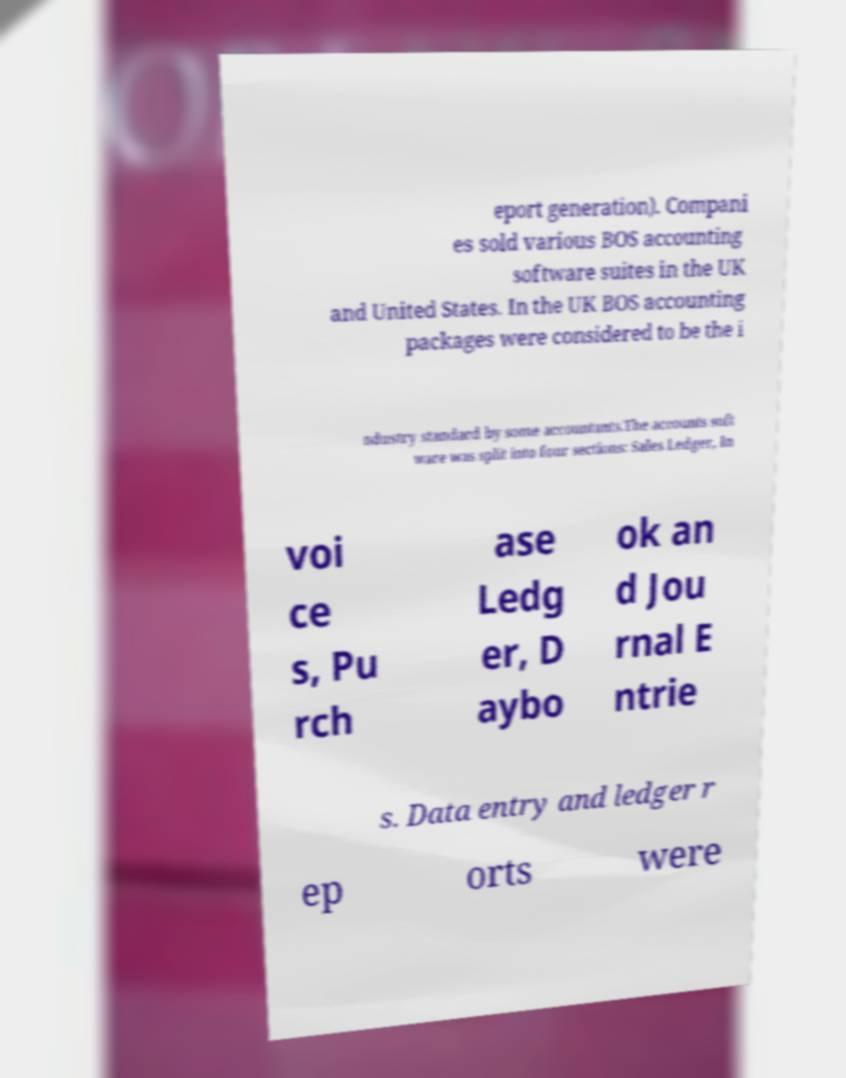For documentation purposes, I need the text within this image transcribed. Could you provide that? eport generation). Compani es sold various BOS accounting software suites in the UK and United States. In the UK BOS accounting packages were considered to be the i ndustry standard by some accountants.The accounts soft ware was split into four sections: Sales Ledger, In voi ce s, Pu rch ase Ledg er, D aybo ok an d Jou rnal E ntrie s. Data entry and ledger r ep orts were 